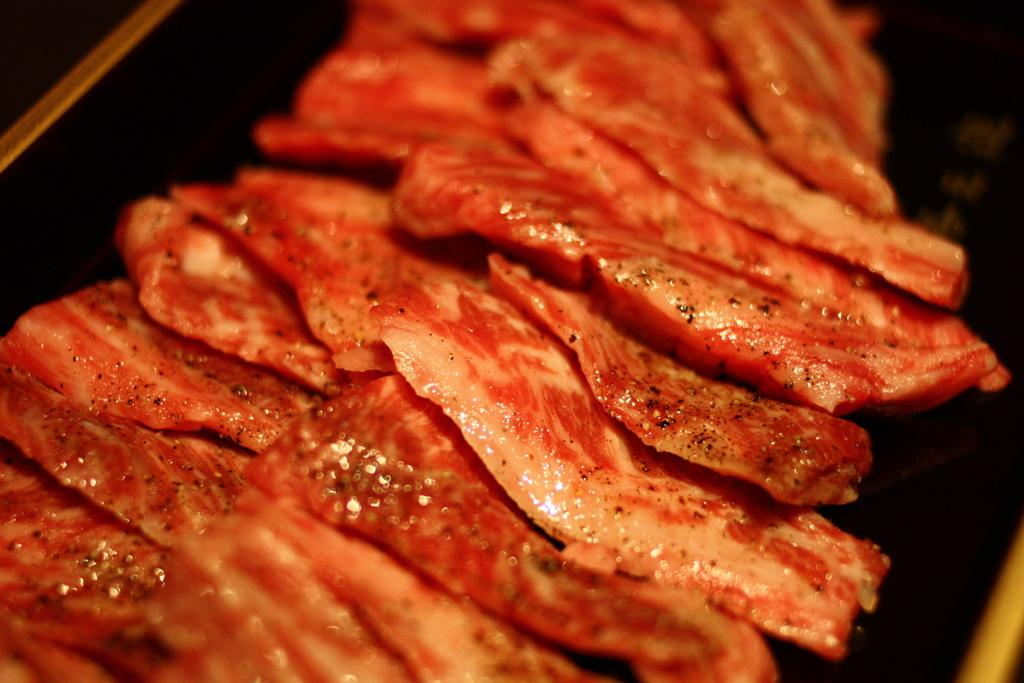What type of food can be seen in the image? There are slices of meat in the image. What is the color of the surface on which the meat is placed? The slices of meat are on a black surface. Where is the black surface located in the image? The black surface is in the foreground of the image. What type of credit card is visible in the image? There is no credit card present in the image; it only features slices of meat on a black surface. 